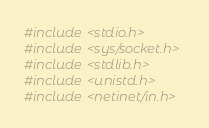<code> <loc_0><loc_0><loc_500><loc_500><_C_>#include <stdio.h>
#include <sys/socket.h>
#include <stdlib.h>
#include <unistd.h>
#include <netinet/in.h></code> 